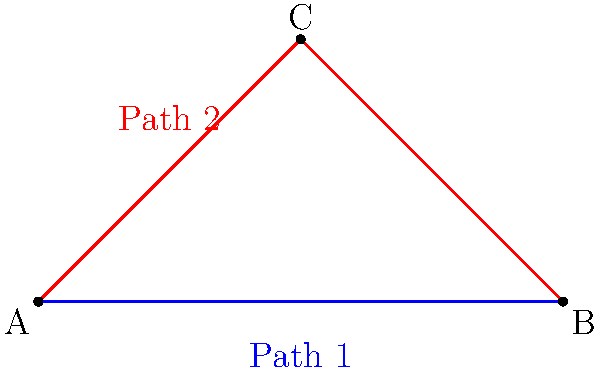In a story plot diagram, two different paths lead from point A (the beginning) to point B (the ending), as shown in the figure. Path 1 (blue) goes directly from A to B, while Path 2 (red) goes through an intermediate point C. Are these two paths homotopy equivalent in the context of storytelling? If so, explain why. To determine if the two paths are homotopy equivalent in the context of storytelling, we need to consider the following steps:

1. Definition: Two paths are homotopy equivalent if one can be continuously deformed into the other without leaving the space.

2. Storytelling context: In plot diagrams, the space represents all possible narrative developments.

3. Path analysis:
   - Path 1 (blue) represents a direct storyline from beginning to end.
   - Path 2 (red) includes an intermediate point C, which could represent a subplot or character development.

4. Continuous deformation: We can imagine gradually moving point C towards the direct line AB, effectively transforming Path 2 into Path 1.

5. Narrative interpretation: This deformation represents simplifying a complex plot (with subplots) into a more straightforward narrative without fundamentally changing the start and end points.

6. Preservation of key elements: Both paths maintain the same beginning (A) and ending (B), which are crucial in storytelling.

7. Flexibility in storytelling: The homotopy equivalence suggests that writers can add or remove complexity (represented by point C) while maintaining the essence of the story.

Therefore, in the context of storytelling, these two paths are indeed homotopy equivalent. This equivalence demonstrates that stories with different levels of complexity can still convey the same fundamental narrative journey.
Answer: Yes, the paths are homotopy equivalent. 